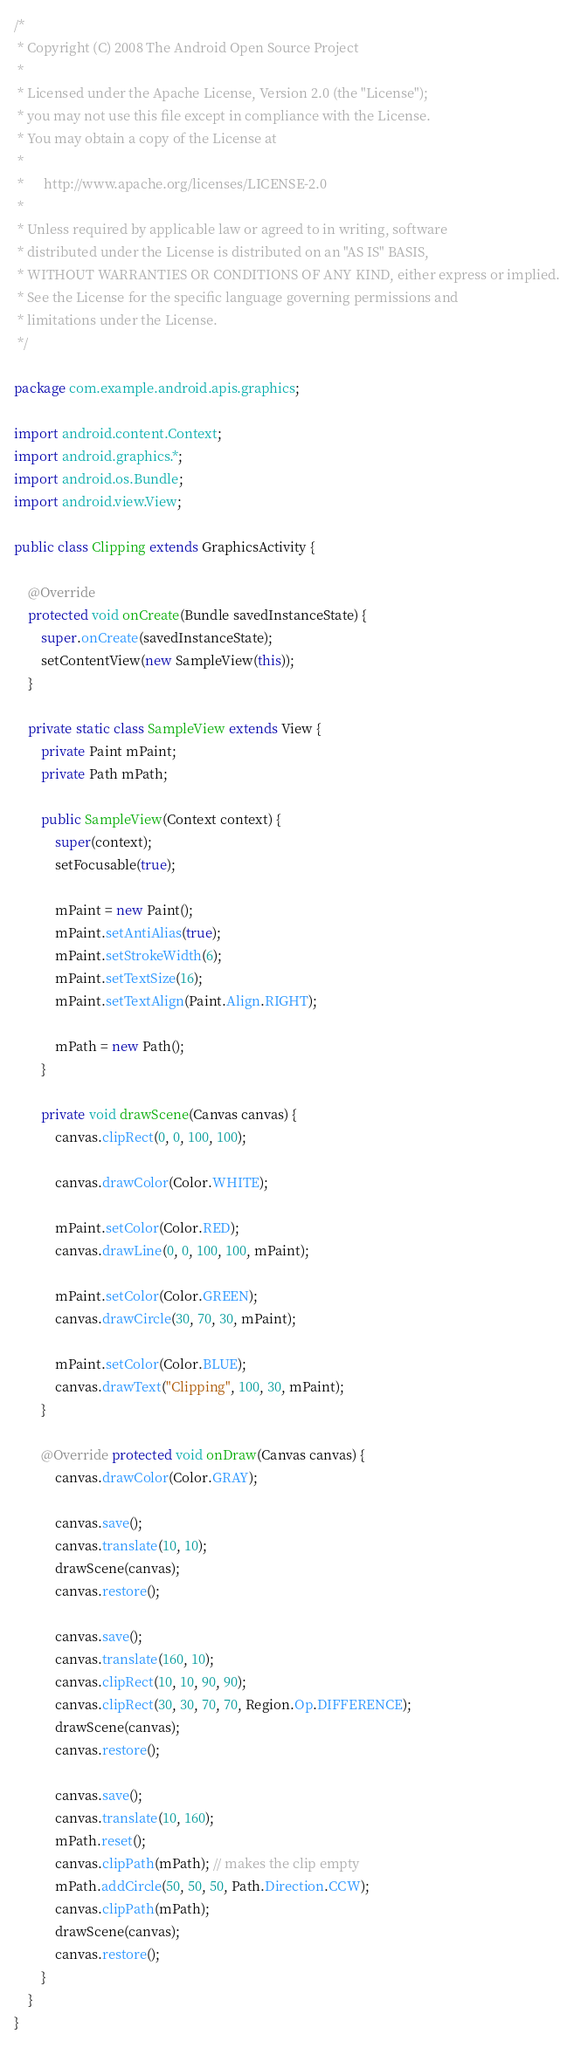<code> <loc_0><loc_0><loc_500><loc_500><_Java_>/*
 * Copyright (C) 2008 The Android Open Source Project
 *
 * Licensed under the Apache License, Version 2.0 (the "License");
 * you may not use this file except in compliance with the License.
 * You may obtain a copy of the License at
 *
 *      http://www.apache.org/licenses/LICENSE-2.0
 *
 * Unless required by applicable law or agreed to in writing, software
 * distributed under the License is distributed on an "AS IS" BASIS,
 * WITHOUT WARRANTIES OR CONDITIONS OF ANY KIND, either express or implied.
 * See the License for the specific language governing permissions and
 * limitations under the License.
 */

package com.example.android.apis.graphics;

import android.content.Context;
import android.graphics.*;
import android.os.Bundle;
import android.view.View;

public class Clipping extends GraphicsActivity {

    @Override
    protected void onCreate(Bundle savedInstanceState) {
        super.onCreate(savedInstanceState);
        setContentView(new SampleView(this));
    }

    private static class SampleView extends View {
        private Paint mPaint;
        private Path mPath;

        public SampleView(Context context) {
            super(context);
            setFocusable(true);

            mPaint = new Paint();
            mPaint.setAntiAlias(true);
            mPaint.setStrokeWidth(6);
            mPaint.setTextSize(16);
            mPaint.setTextAlign(Paint.Align.RIGHT);

            mPath = new Path();
        }

        private void drawScene(Canvas canvas) {
            canvas.clipRect(0, 0, 100, 100);

            canvas.drawColor(Color.WHITE);

            mPaint.setColor(Color.RED);
            canvas.drawLine(0, 0, 100, 100, mPaint);

            mPaint.setColor(Color.GREEN);
            canvas.drawCircle(30, 70, 30, mPaint);

            mPaint.setColor(Color.BLUE);
            canvas.drawText("Clipping", 100, 30, mPaint);
        }

        @Override protected void onDraw(Canvas canvas) {
            canvas.drawColor(Color.GRAY);

            canvas.save();
            canvas.translate(10, 10);
            drawScene(canvas);
            canvas.restore();

            canvas.save();
            canvas.translate(160, 10);
            canvas.clipRect(10, 10, 90, 90);
            canvas.clipRect(30, 30, 70, 70, Region.Op.DIFFERENCE);
            drawScene(canvas);
            canvas.restore();

            canvas.save();
            canvas.translate(10, 160);
            mPath.reset();
            canvas.clipPath(mPath); // makes the clip empty
            mPath.addCircle(50, 50, 50, Path.Direction.CCW);
            canvas.clipPath(mPath);
            drawScene(canvas);
            canvas.restore();
        }
    }
}

</code> 